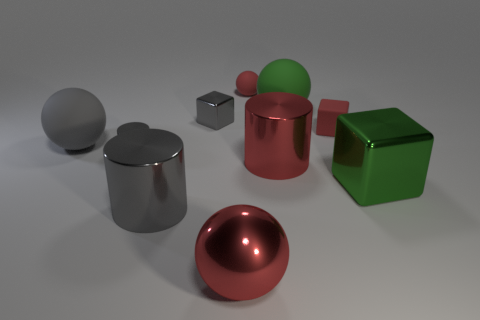Is there any other thing that has the same color as the big metal sphere?
Your response must be concise. Yes. There is a small gray object in front of the matte sphere that is to the left of the small metal block; what is it made of?
Ensure brevity in your answer.  Metal. Are the tiny red block and the green object behind the tiny red rubber cube made of the same material?
Ensure brevity in your answer.  Yes. How many things are rubber things that are to the right of the big gray shiny cylinder or metallic cubes?
Provide a succinct answer. 5. Is there a big metallic ball that has the same color as the tiny matte ball?
Provide a succinct answer. Yes. There is a green rubber object; does it have the same shape as the object behind the green matte object?
Your answer should be compact. Yes. How many matte balls are both on the left side of the large green sphere and behind the red cube?
Keep it short and to the point. 1. There is a large red object that is the same shape as the big gray matte thing; what is its material?
Your answer should be very brief. Metal. There is a red rubber thing to the left of the big green object that is behind the red metallic cylinder; what is its size?
Offer a terse response. Small. Is there a large cyan rubber block?
Make the answer very short. No. 